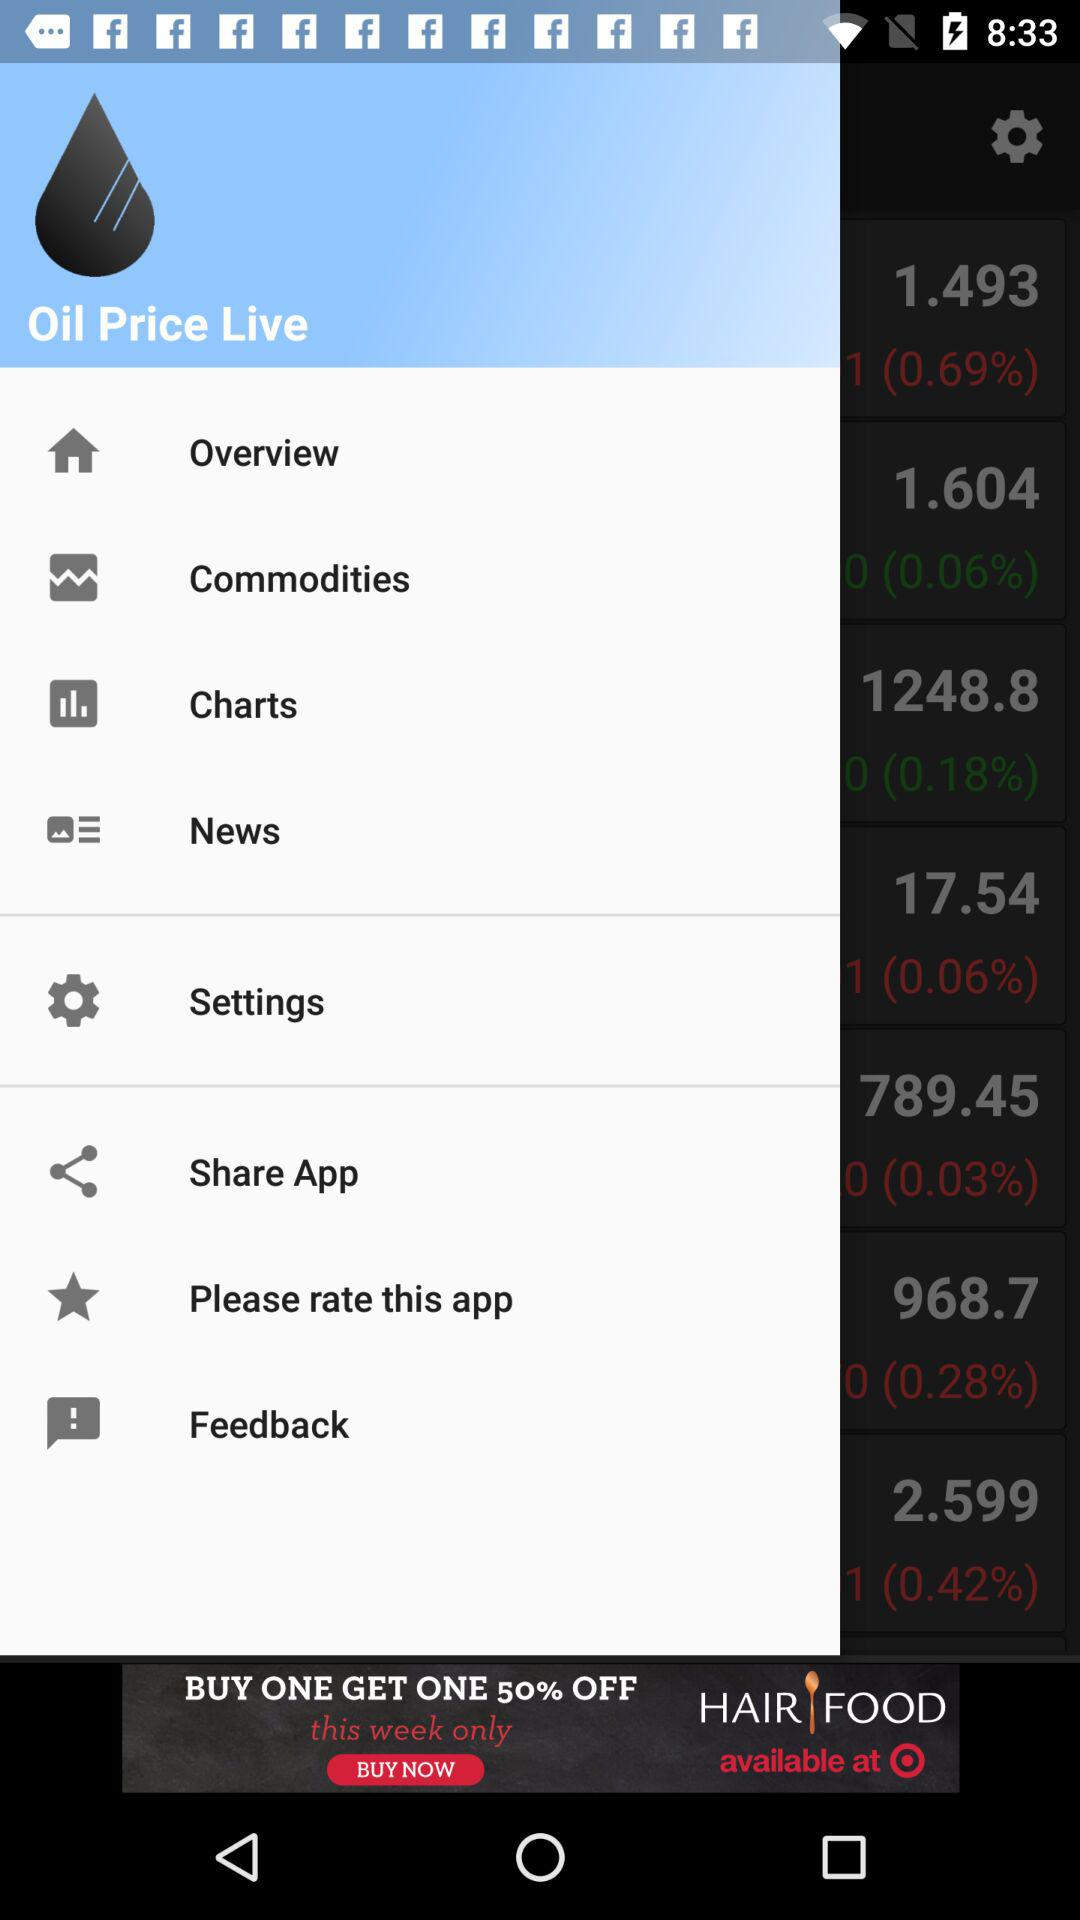Which applications are available for sharing?
When the provided information is insufficient, respond with <no answer>. <no answer> 